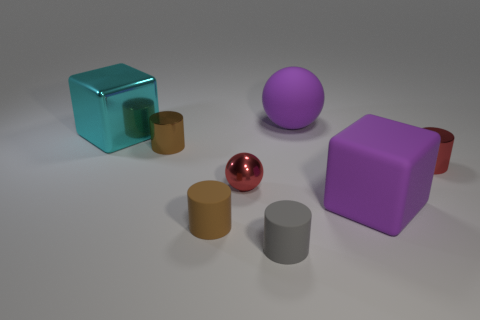Subtract all cyan cubes. Subtract all red balls. How many cubes are left? 1 Add 2 brown blocks. How many objects exist? 10 Subtract all balls. How many objects are left? 6 Add 2 tiny gray things. How many tiny gray things exist? 3 Subtract 0 brown spheres. How many objects are left? 8 Subtract all gray rubber things. Subtract all large purple blocks. How many objects are left? 6 Add 8 rubber cylinders. How many rubber cylinders are left? 10 